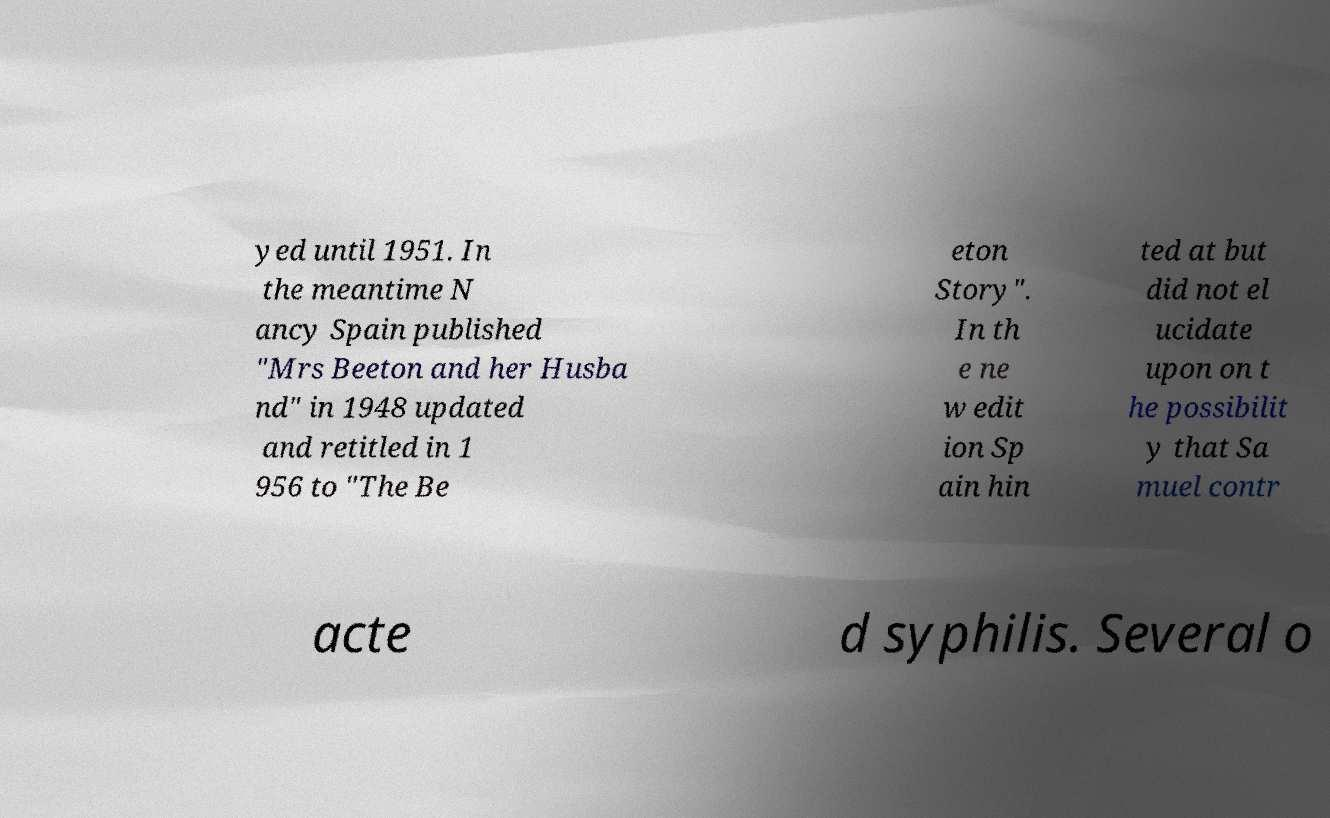Please read and relay the text visible in this image. What does it say? yed until 1951. In the meantime N ancy Spain published "Mrs Beeton and her Husba nd" in 1948 updated and retitled in 1 956 to "The Be eton Story". In th e ne w edit ion Sp ain hin ted at but did not el ucidate upon on t he possibilit y that Sa muel contr acte d syphilis. Several o 